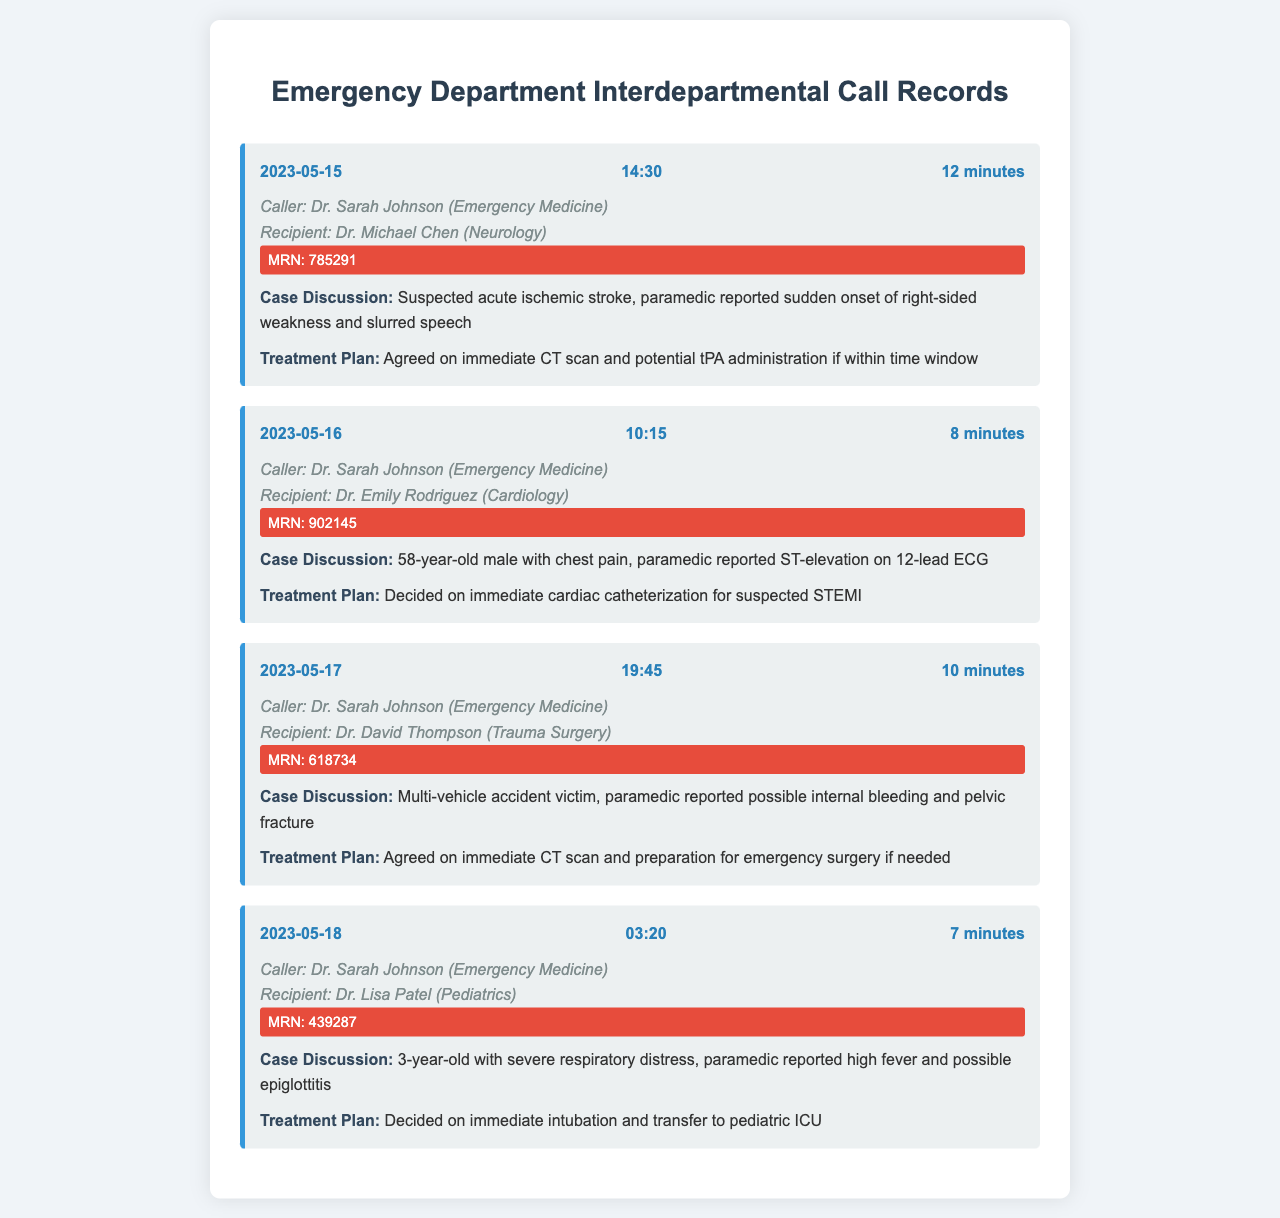what is the date of the first call? The first call is dated 2023-05-15 as noted in the document.
Answer: 2023-05-15 who was the caller in the second call? The caller in the second call was Dr. Sarah Johnson from Emergency Medicine.
Answer: Dr. Sarah Johnson what was the patient ID for the call about the 3-year-old? The patient ID for the 3-year-old with severe respiratory distress is MRN: 439287.
Answer: MRN: 439287 what treatment was agreed upon for the suspected acute ischemic stroke? The treatment agreed upon was an immediate CT scan and potential tPA administration if within time window.
Answer: immediate CT scan and potential tPA administration how many minutes did the call with Dr. Michael Chen last? The call with Dr. Michael Chen lasted for 12 minutes, as indicated in the call duration.
Answer: 12 minutes which specialist was involved in the case discussion of the 58-year-old male with chest pain? The specialist involved in this case discussion was Dr. Emily Rodriguez from Cardiology.
Answer: Dr. Emily Rodriguez what did the paramedic report for the multi-vehicle accident victim? The paramedic reported possible internal bleeding and pelvic fracture for the multi-vehicle accident victim.
Answer: possible internal bleeding and pelvic fracture what time did the call with Dr. Lisa Patel take place? The call with Dr. Lisa Patel took place at 03:20 as noted in the call header.
Answer: 03:20 